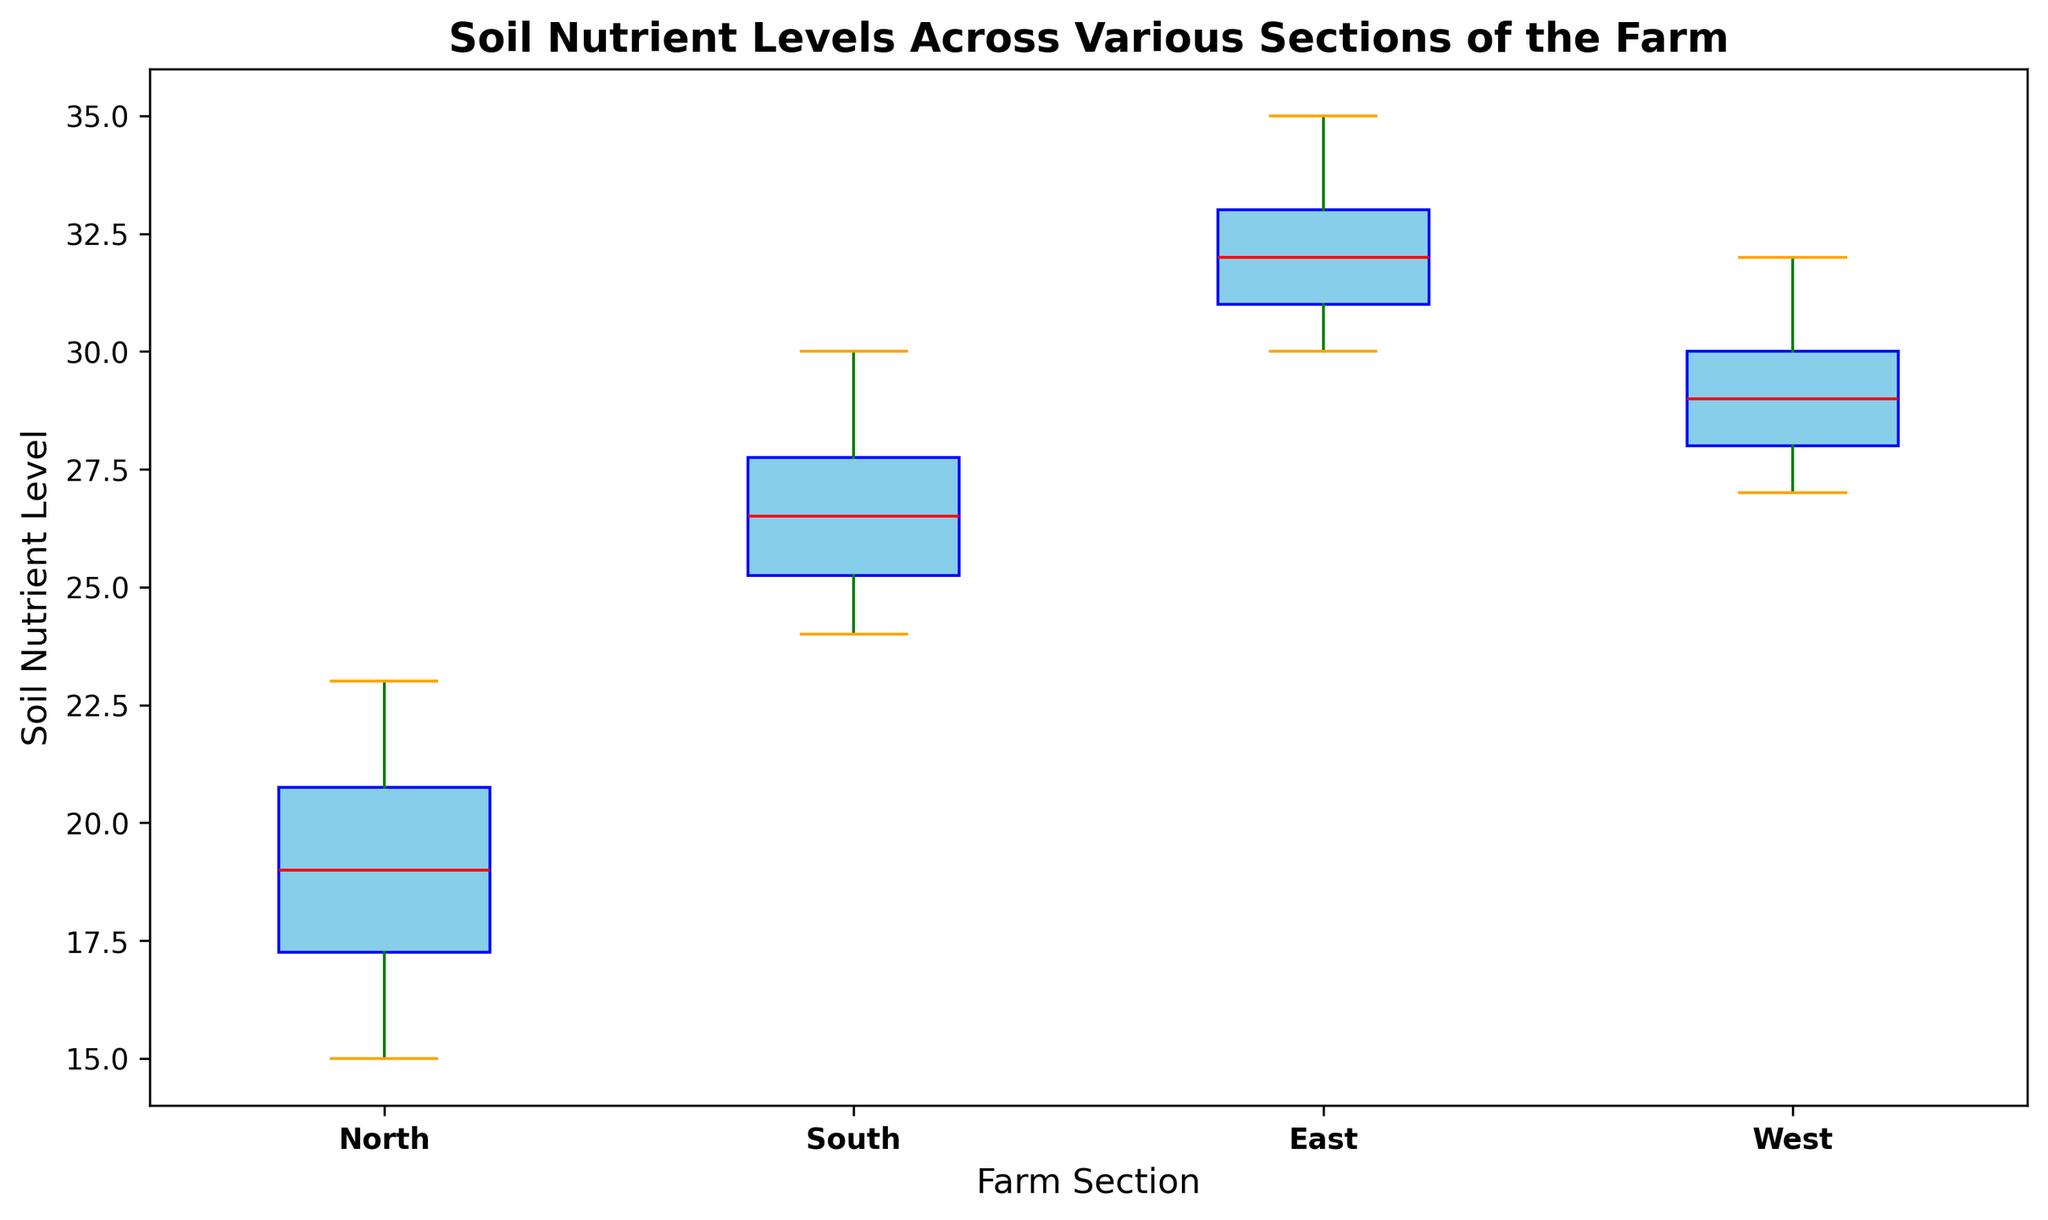What is the median soil nutrient level for the East section? The median value is represented by the red line inside the East section’s box. To find the median, locate the red line within the box corresponding to the East section.
Answer: 32.5 Which section has the highest variability in soil nutrient levels? Variability can be assessed by looking at the height of the boxes and the length of the whiskers. The section with the tallest box and longest whiskers has the highest variability.
Answer: North What is the range of soil nutrient levels in the South section? The range is the difference between the maximum and minimum values represented by the top and bottom whiskers. Check the highest point of the top whisker and the lowest point of the bottom whisker in the South section.
Answer: 6 (30 - 24) Are the median nutrient levels in the North section higher or lower than in the West section? Compare the positions of the red lines in the North and West section boxes. If the red line in the North section is above the red line in the West section, it is higher; otherwise, it is lower.
Answer: Lower Which section has the smallest interquartile range (IQR) for soil nutrient levels? The IQR is represented by the height of the box (the distance between the bottom and top edges of the box). The section with the shortest box has the smallest IQR.
Answer: East Is there any overlap in soil nutrient levels between the North and West sections? Overlap occurs if the whiskers of one section intersect with the whiskers or the box of the other section. Look at where the whiskers extend for both North and West sections to determine if they overlap.
Answer: Yes How does the median soil nutrient level in the North section compare to the first quartile (Q1) of the West section? Q1 for the West section is the bottom edge of its box. Compare the red line inside the North section’s box (median) with the bottom edge of the West section’s box.
Answer: Median in North is lower What is the combined median soil nutrient level of the South and East sections? Find the median for both South and East sections (the red lines within their respective boxes). Calculate the average of these two medians. Median for South is 26, and for East is 32.5: (26 + 32.5) / 2 = 29.25
Answer: 29.25 Which section has the most consistent soil nutrient levels? Consistency is indicated by the smallest spread, indicated by a shorter box and shorter whiskers. The section with the shortest overall vertical span has the most consistent levels.
Answer: West What is the difference between the third quartiles (Q3) of the North and South sections? Find Q3 for both sections (the top edge of their respective boxes). The difference is calculated by subtracting Q3 of the North from Q3 of the South. Q3 for North is 21.5 and for South is 27.5: 27.5 - 21.5 = 6
Answer: 6 